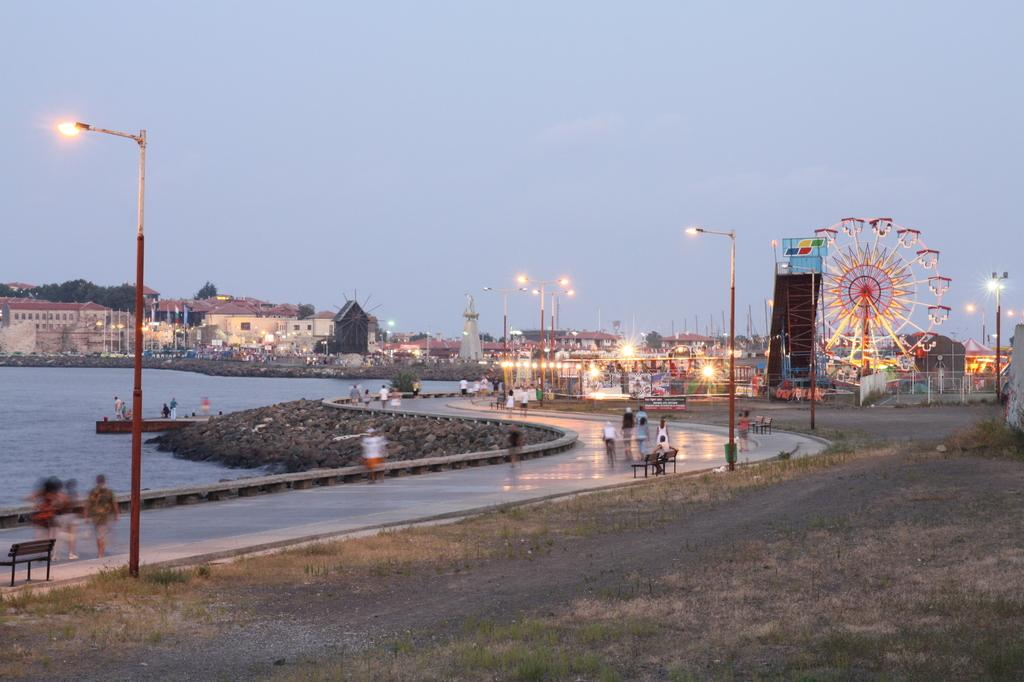What structures can be seen in the image? There are poles, lights, buildings, and benches visible in the image. What type of vegetation is present in the image? There are trees in the image. What is the joint wheel used for in the image? The joint wheel is likely used for connecting or supporting structures in the image. Are there any people present in the image? Yes, there are people on the road in the image. What natural element is visible in the image? Water is visible in the image. What can be seen in the background of the image? The sky is visible in the background of the image. What type of star can be seen in the bedroom in the image? There is no bedroom or star present in the image. Are the people in the image engaged in a fight? There is no indication of a fight or any conflict in the image. 